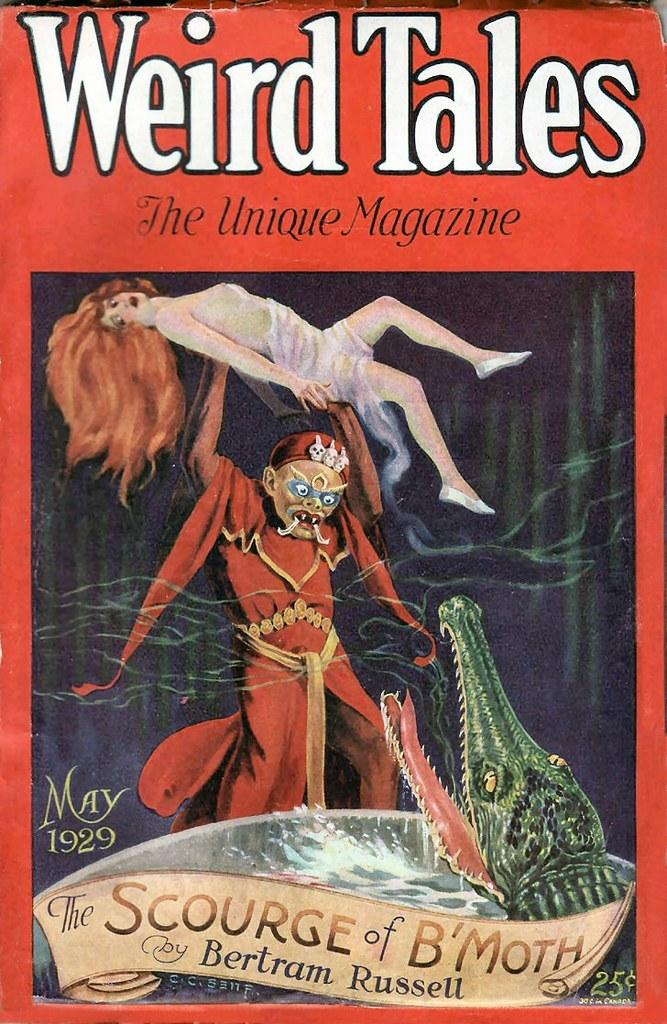What is featured on the poster in the image? The poster depicts a man lifting a woman. What else can be seen in the image besides the poster? There is a boat, water, and a crocodile visible in the image. Can you describe the boat in the image? The boat has text on it. What is the setting of the image? The image contains water, suggesting a water-based environment. How many beans are present in the image? There are no beans visible in the image. What direction is the net facing in the image? There is no net present in the image. 